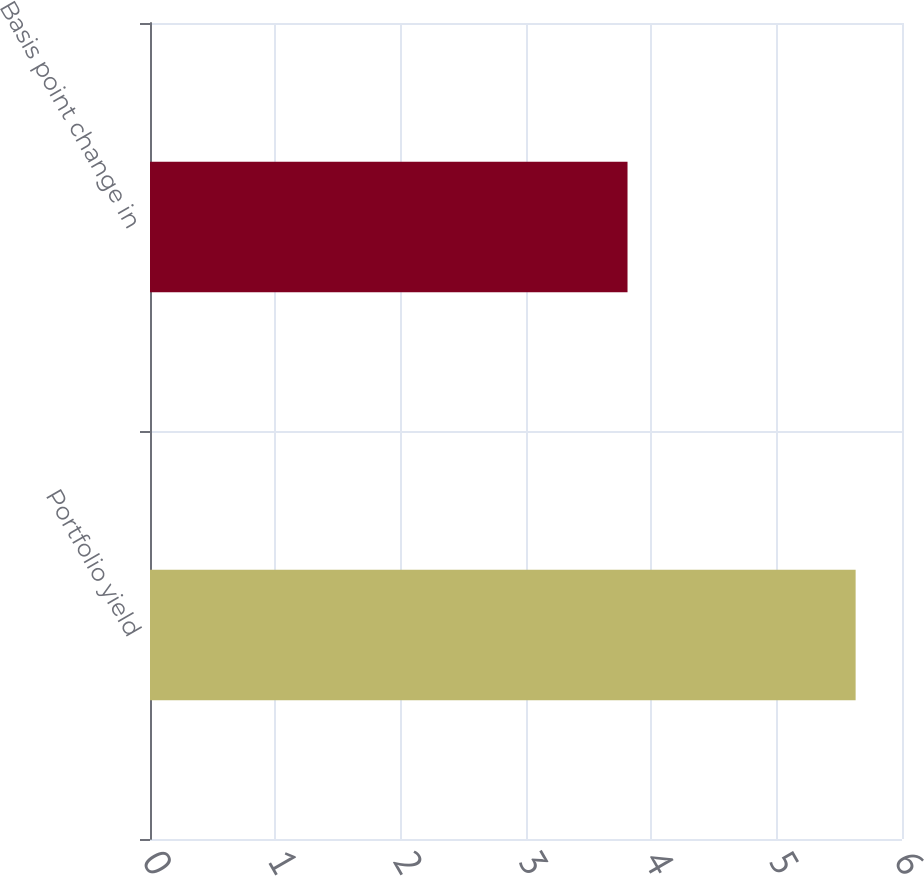Convert chart. <chart><loc_0><loc_0><loc_500><loc_500><bar_chart><fcel>Portfolio yield<fcel>Basis point change in<nl><fcel>5.63<fcel>3.81<nl></chart> 